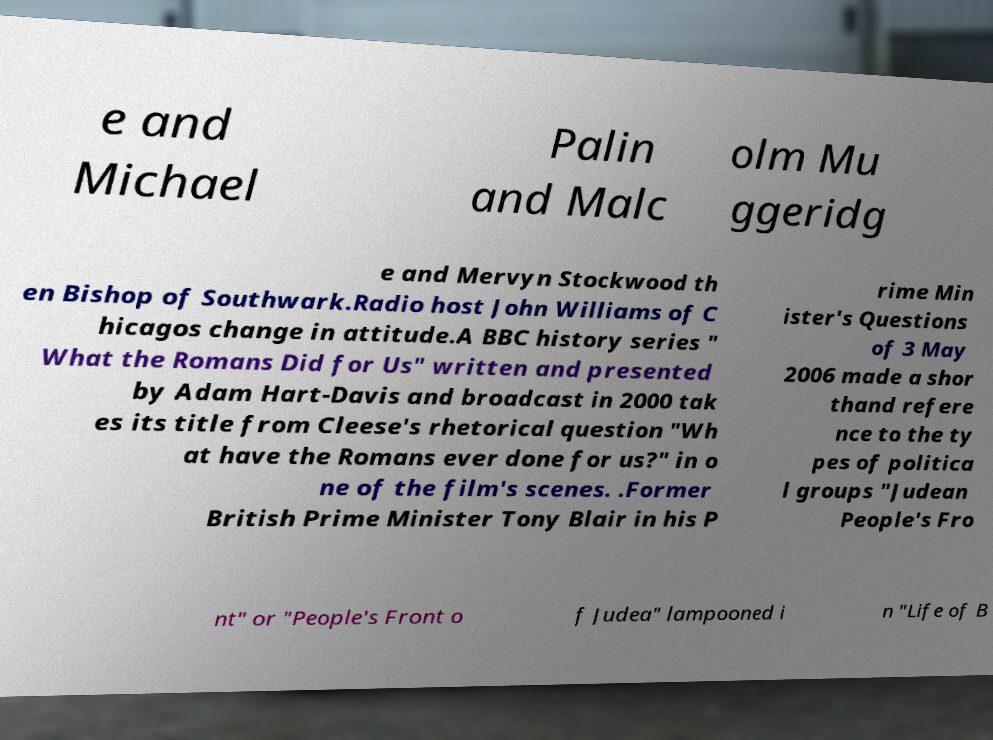There's text embedded in this image that I need extracted. Can you transcribe it verbatim? e and Michael Palin and Malc olm Mu ggeridg e and Mervyn Stockwood th en Bishop of Southwark.Radio host John Williams of C hicagos change in attitude.A BBC history series " What the Romans Did for Us" written and presented by Adam Hart-Davis and broadcast in 2000 tak es its title from Cleese's rhetorical question "Wh at have the Romans ever done for us?" in o ne of the film's scenes. .Former British Prime Minister Tony Blair in his P rime Min ister's Questions of 3 May 2006 made a shor thand refere nce to the ty pes of politica l groups "Judean People's Fro nt" or "People's Front o f Judea" lampooned i n "Life of B 